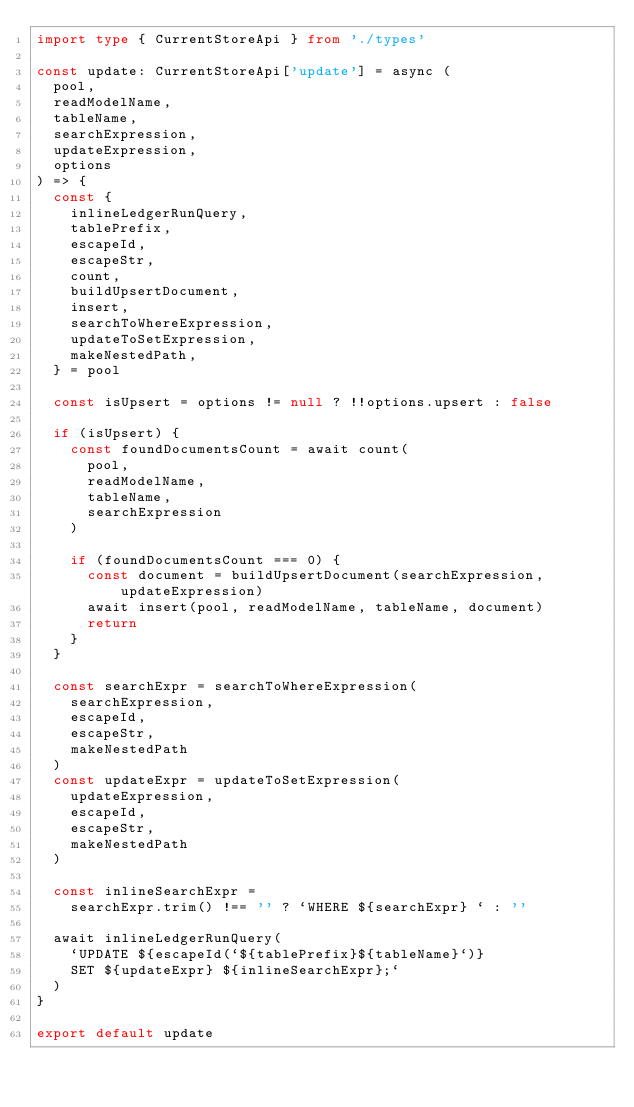Convert code to text. <code><loc_0><loc_0><loc_500><loc_500><_TypeScript_>import type { CurrentStoreApi } from './types'

const update: CurrentStoreApi['update'] = async (
  pool,
  readModelName,
  tableName,
  searchExpression,
  updateExpression,
  options
) => {
  const {
    inlineLedgerRunQuery,
    tablePrefix,
    escapeId,
    escapeStr,
    count,
    buildUpsertDocument,
    insert,
    searchToWhereExpression,
    updateToSetExpression,
    makeNestedPath,
  } = pool

  const isUpsert = options != null ? !!options.upsert : false

  if (isUpsert) {
    const foundDocumentsCount = await count(
      pool,
      readModelName,
      tableName,
      searchExpression
    )

    if (foundDocumentsCount === 0) {
      const document = buildUpsertDocument(searchExpression, updateExpression)
      await insert(pool, readModelName, tableName, document)
      return
    }
  }

  const searchExpr = searchToWhereExpression(
    searchExpression,
    escapeId,
    escapeStr,
    makeNestedPath
  )
  const updateExpr = updateToSetExpression(
    updateExpression,
    escapeId,
    escapeStr,
    makeNestedPath
  )

  const inlineSearchExpr =
    searchExpr.trim() !== '' ? `WHERE ${searchExpr} ` : ''

  await inlineLedgerRunQuery(
    `UPDATE ${escapeId(`${tablePrefix}${tableName}`)}
    SET ${updateExpr} ${inlineSearchExpr};`
  )
}

export default update
</code> 